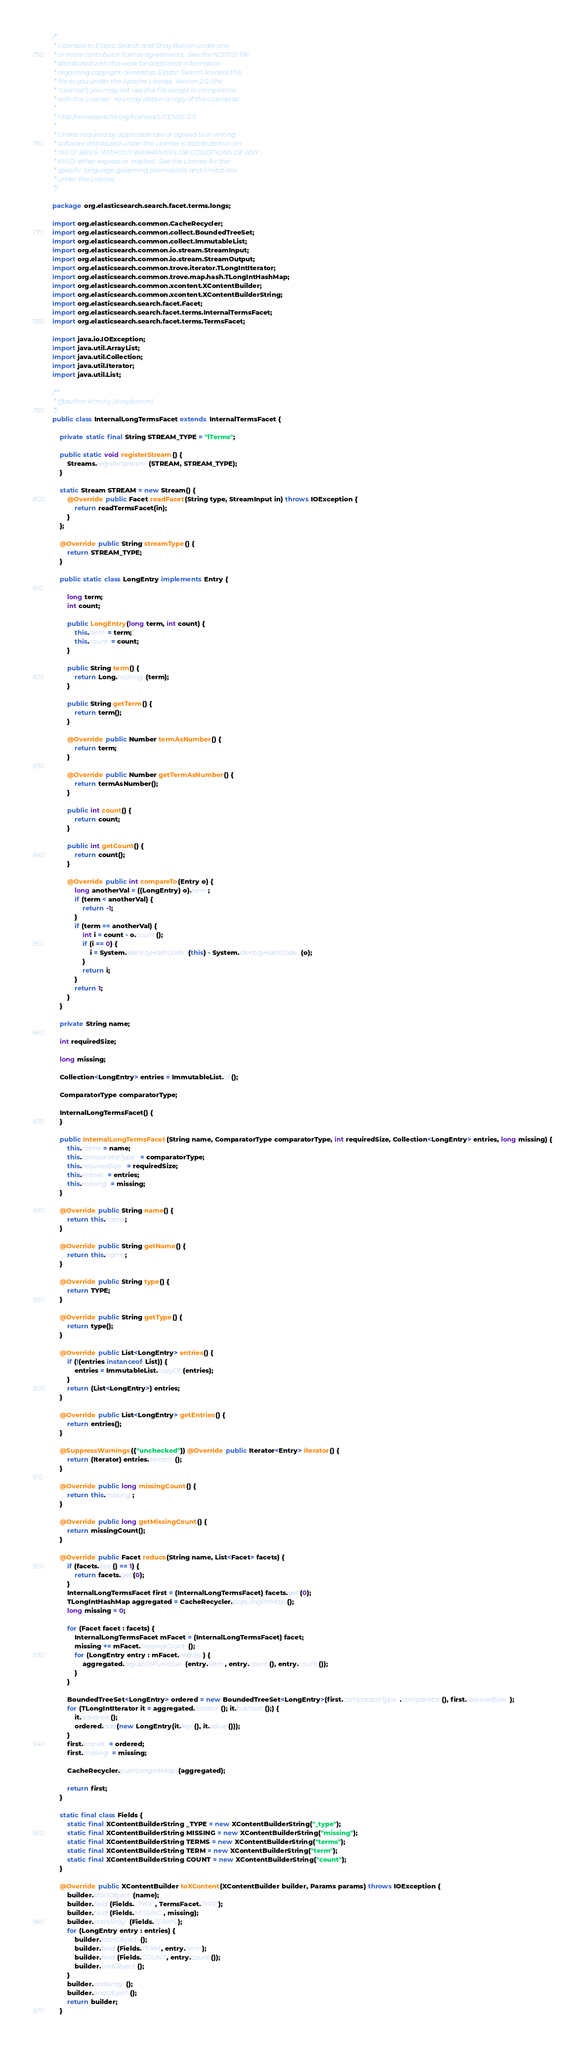Convert code to text. <code><loc_0><loc_0><loc_500><loc_500><_Java_>/*
 * Licensed to Elastic Search and Shay Banon under one
 * or more contributor license agreements.  See the NOTICE file
 * distributed with this work for additional information
 * regarding copyright ownership. Elastic Search licenses this
 * file to you under the Apache License, Version 2.0 (the
 * "License"); you may not use this file except in compliance
 * with the License.  You may obtain a copy of the License at
 *
 * http://www.apache.org/licenses/LICENSE-2.0
 *
 * Unless required by applicable law or agreed to in writing,
 * software distributed under the License is distributed on an
 * "AS IS" BASIS, WITHOUT WARRANTIES OR CONDITIONS OF ANY
 * KIND, either express or implied.  See the License for the
 * specific language governing permissions and limitations
 * under the License.
 */

package org.elasticsearch.search.facet.terms.longs;

import org.elasticsearch.common.CacheRecycler;
import org.elasticsearch.common.collect.BoundedTreeSet;
import org.elasticsearch.common.collect.ImmutableList;
import org.elasticsearch.common.io.stream.StreamInput;
import org.elasticsearch.common.io.stream.StreamOutput;
import org.elasticsearch.common.trove.iterator.TLongIntIterator;
import org.elasticsearch.common.trove.map.hash.TLongIntHashMap;
import org.elasticsearch.common.xcontent.XContentBuilder;
import org.elasticsearch.common.xcontent.XContentBuilderString;
import org.elasticsearch.search.facet.Facet;
import org.elasticsearch.search.facet.terms.InternalTermsFacet;
import org.elasticsearch.search.facet.terms.TermsFacet;

import java.io.IOException;
import java.util.ArrayList;
import java.util.Collection;
import java.util.Iterator;
import java.util.List;

/**
 * @author kimchy (shay.banon)
 */
public class InternalLongTermsFacet extends InternalTermsFacet {

    private static final String STREAM_TYPE = "lTerms";

    public static void registerStream() {
        Streams.registerStream(STREAM, STREAM_TYPE);
    }

    static Stream STREAM = new Stream() {
        @Override public Facet readFacet(String type, StreamInput in) throws IOException {
            return readTermsFacet(in);
        }
    };

    @Override public String streamType() {
        return STREAM_TYPE;
    }

    public static class LongEntry implements Entry {

        long term;
        int count;

        public LongEntry(long term, int count) {
            this.term = term;
            this.count = count;
        }

        public String term() {
            return Long.toString(term);
        }

        public String getTerm() {
            return term();
        }

        @Override public Number termAsNumber() {
            return term;
        }

        @Override public Number getTermAsNumber() {
            return termAsNumber();
        }

        public int count() {
            return count;
        }

        public int getCount() {
            return count();
        }

        @Override public int compareTo(Entry o) {
            long anotherVal = ((LongEntry) o).term;
            if (term < anotherVal) {
                return -1;
            }
            if (term == anotherVal) {
                int i = count - o.count();
                if (i == 0) {
                    i = System.identityHashCode(this) - System.identityHashCode(o);
                }
                return i;
            }
            return 1;
        }
    }

    private String name;

    int requiredSize;

    long missing;

    Collection<LongEntry> entries = ImmutableList.of();

    ComparatorType comparatorType;

    InternalLongTermsFacet() {
    }

    public InternalLongTermsFacet(String name, ComparatorType comparatorType, int requiredSize, Collection<LongEntry> entries, long missing) {
        this.name = name;
        this.comparatorType = comparatorType;
        this.requiredSize = requiredSize;
        this.entries = entries;
        this.missing = missing;
    }

    @Override public String name() {
        return this.name;
    }

    @Override public String getName() {
        return this.name;
    }

    @Override public String type() {
        return TYPE;
    }

    @Override public String getType() {
        return type();
    }

    @Override public List<LongEntry> entries() {
        if (!(entries instanceof List)) {
            entries = ImmutableList.copyOf(entries);
        }
        return (List<LongEntry>) entries;
    }

    @Override public List<LongEntry> getEntries() {
        return entries();
    }

    @SuppressWarnings({"unchecked"}) @Override public Iterator<Entry> iterator() {
        return (Iterator) entries.iterator();
    }

    @Override public long missingCount() {
        return this.missing;
    }

    @Override public long getMissingCount() {
        return missingCount();
    }

    @Override public Facet reduce(String name, List<Facet> facets) {
        if (facets.size() == 1) {
            return facets.get(0);
        }
        InternalLongTermsFacet first = (InternalLongTermsFacet) facets.get(0);
        TLongIntHashMap aggregated = CacheRecycler.popLongIntMap();
        long missing = 0;

        for (Facet facet : facets) {
            InternalLongTermsFacet mFacet = (InternalLongTermsFacet) facet;
            missing += mFacet.missingCount();
            for (LongEntry entry : mFacet.entries) {
                aggregated.adjustOrPutValue(entry.term, entry.count(), entry.count());
            }
        }

        BoundedTreeSet<LongEntry> ordered = new BoundedTreeSet<LongEntry>(first.comparatorType.comparator(), first.requiredSize);
        for (TLongIntIterator it = aggregated.iterator(); it.hasNext();) {
            it.advance();
            ordered.add(new LongEntry(it.key(), it.value()));
        }
        first.entries = ordered;
        first.missing = missing;

        CacheRecycler.pushLongIntMap(aggregated);

        return first;
    }

    static final class Fields {
        static final XContentBuilderString _TYPE = new XContentBuilderString("_type");
        static final XContentBuilderString MISSING = new XContentBuilderString("missing");
        static final XContentBuilderString TERMS = new XContentBuilderString("terms");
        static final XContentBuilderString TERM = new XContentBuilderString("term");
        static final XContentBuilderString COUNT = new XContentBuilderString("count");
    }

    @Override public XContentBuilder toXContent(XContentBuilder builder, Params params) throws IOException {
        builder.startObject(name);
        builder.field(Fields._TYPE, TermsFacet.TYPE);
        builder.field(Fields.MISSING, missing);
        builder.startArray(Fields.TERMS);
        for (LongEntry entry : entries) {
            builder.startObject();
            builder.field(Fields.TERM, entry.term);
            builder.field(Fields.COUNT, entry.count());
            builder.endObject();
        }
        builder.endArray();
        builder.endObject();
        return builder;
    }
</code> 